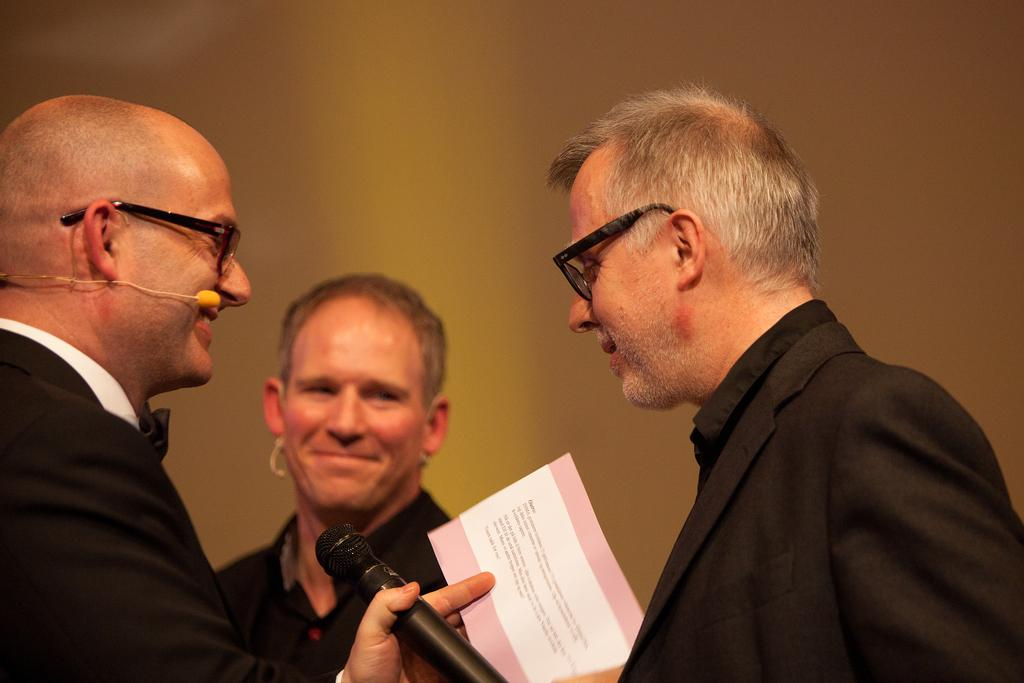What is the person on the left side of the image holding in their hands? The person on the left side of the image is holding a mic and a paper in their hands. What is the relationship between the person with the mic and the person standing in front of them? The person standing in front of the person with the mic is likely the subject or focus of the person holding the mic. Can you describe the third person in the image? The third person is in the background of the image, but their specific actions or appearance are not mentioned in the provided facts. What type of art can be seen in the fog at the seashore in the image? There is no mention of fog, seashore, or art in the provided facts, so this question cannot be answered based on the information given. 